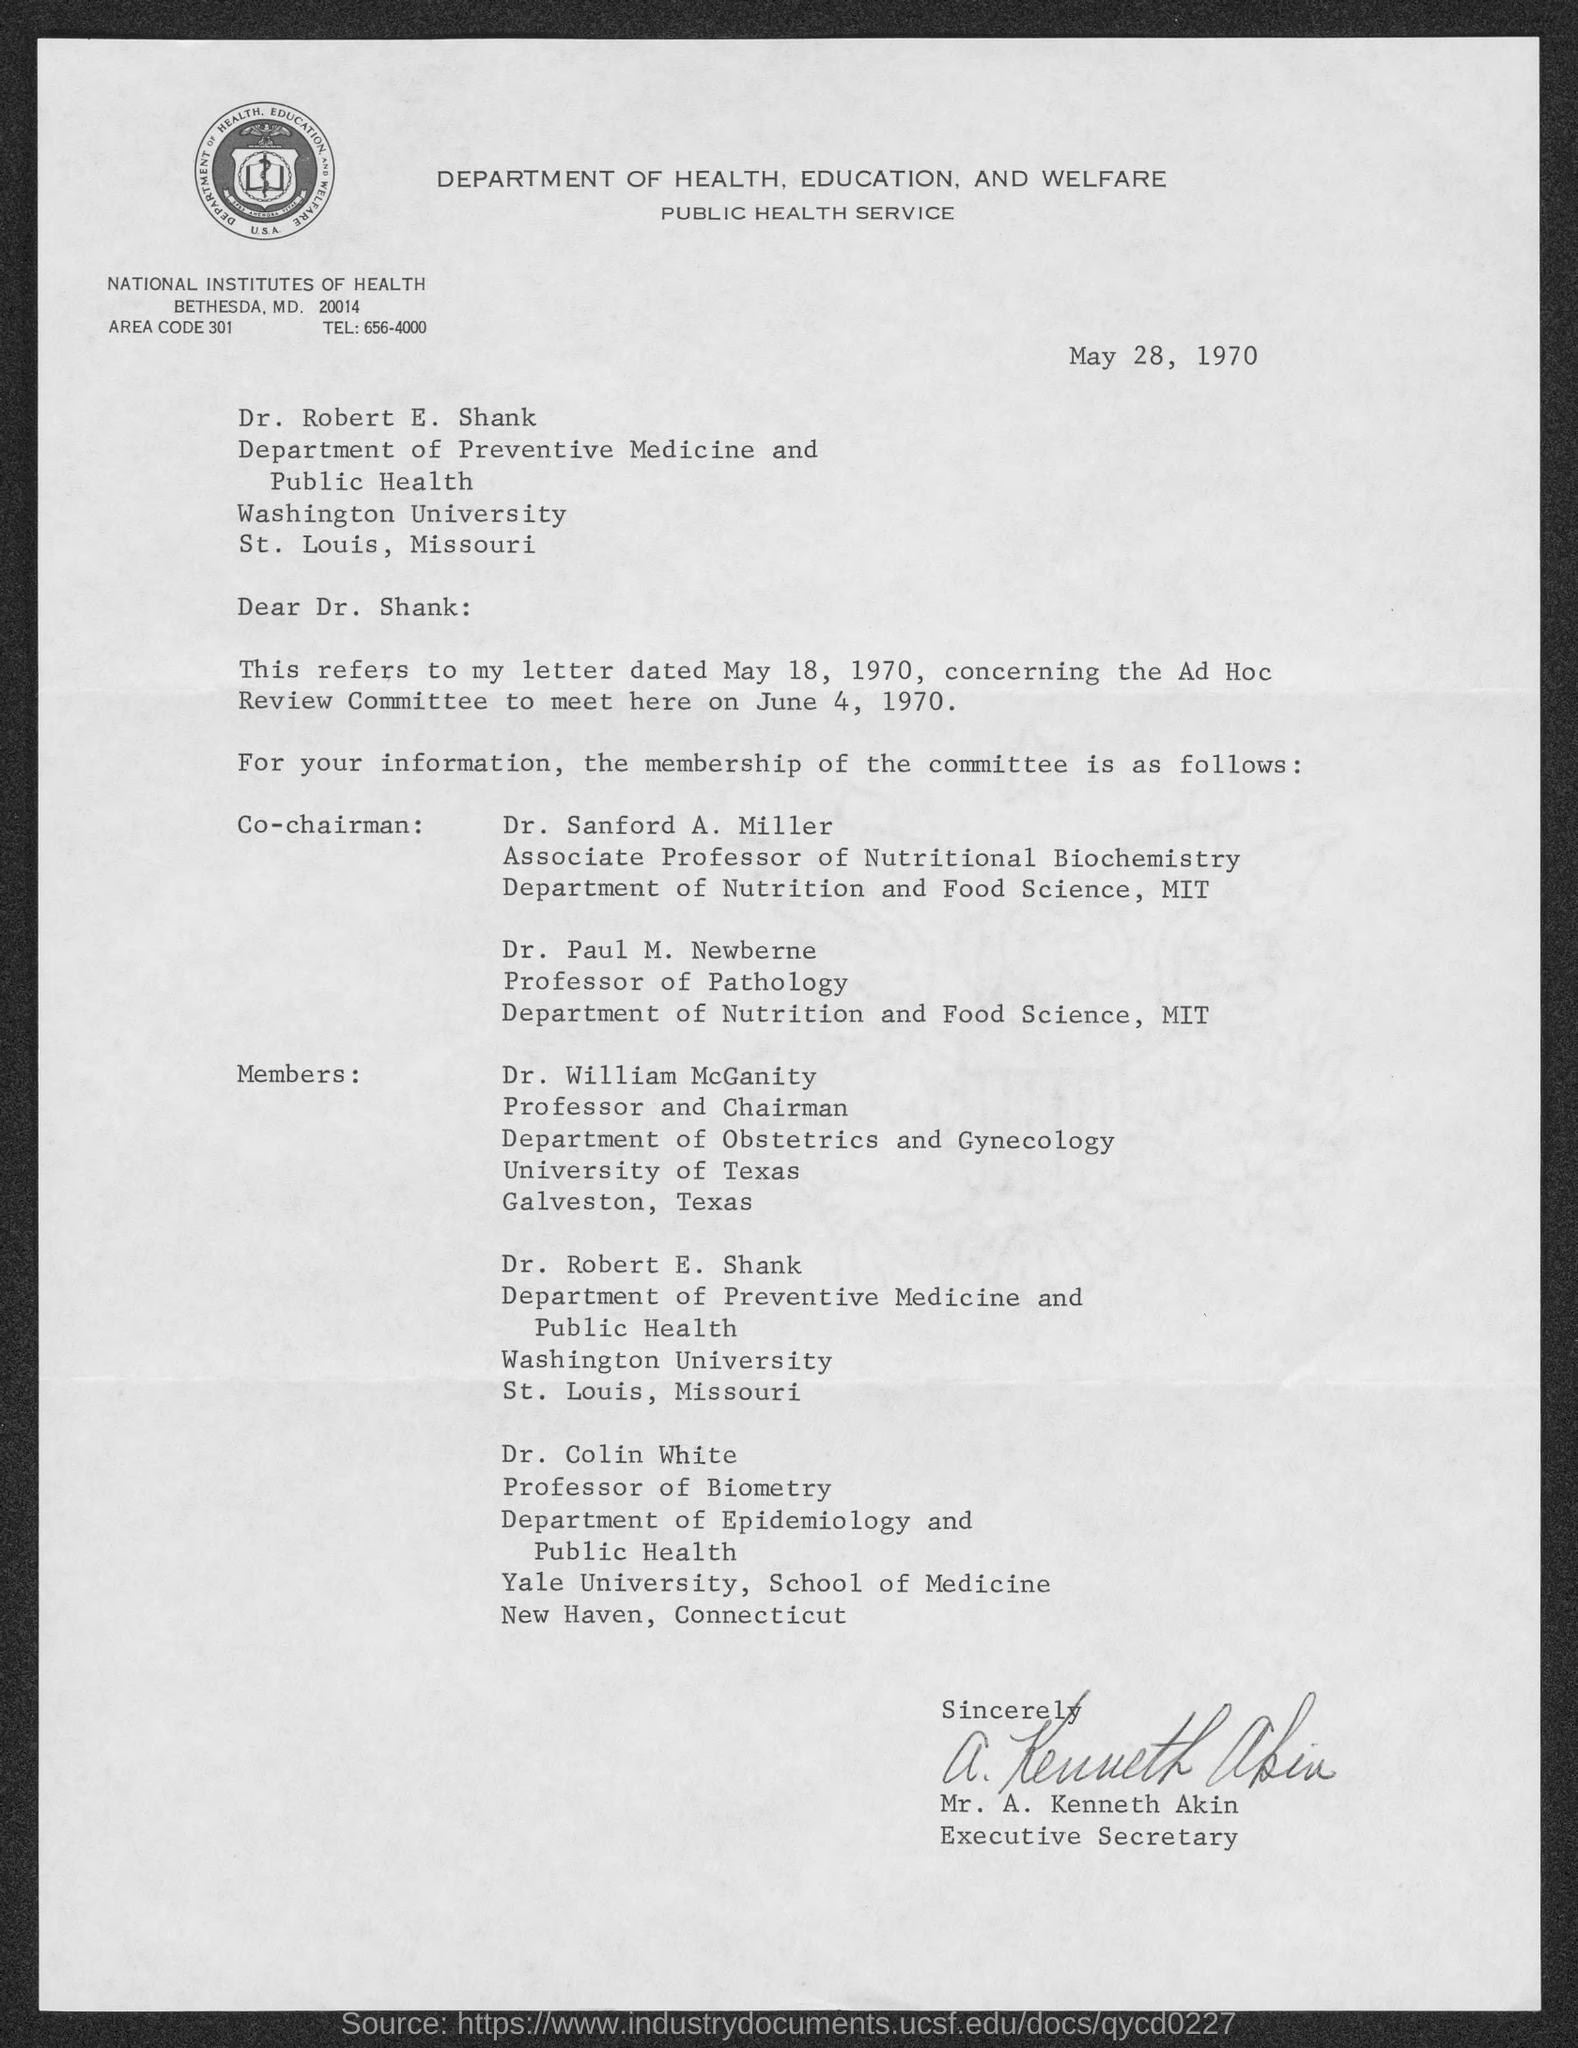Mention a couple of crucial points in this snapshot. The Ad Hoc Meeting Review Committee will take place on June 4, 1970. The date on the document is May 28, 1970. The telephone number for the National Institutes of Health is 656-4000. The letter is from Mr. A. Kenneth Akin. The letter dated May 18, 1970, refers to something. 